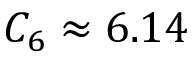Convert formula to latex. <formula><loc_0><loc_0><loc_500><loc_500>C _ { 6 } \approx 6 . 1 4</formula> 